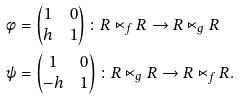<formula> <loc_0><loc_0><loc_500><loc_500>\phi & = \begin{pmatrix} 1 & 0 \\ h & 1 \end{pmatrix} \colon R \ltimes _ { f } R \to R \ltimes _ { g } R \\ \psi & = \begin{pmatrix} 1 & 0 \\ - h & 1 \end{pmatrix} \colon R \ltimes _ { g } R \to R \ltimes _ { f } R .</formula> 